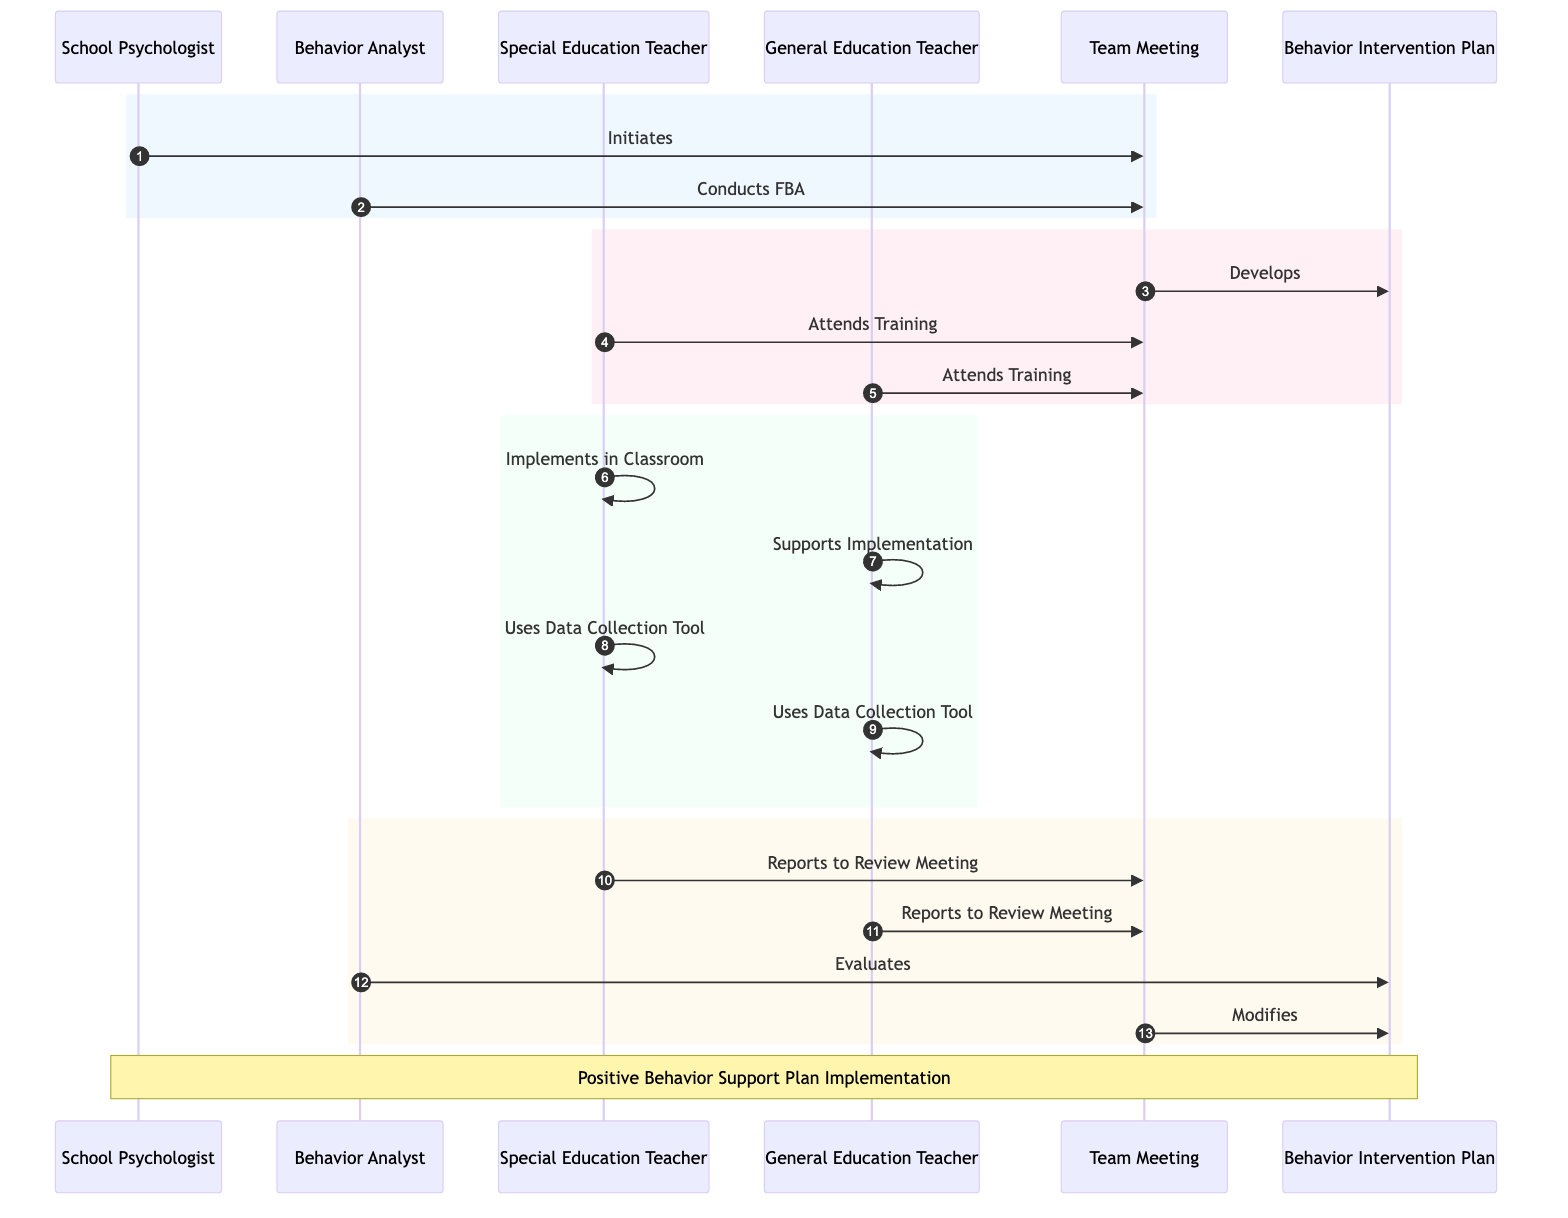What is the first action initiated in this sequence? The first action depicted in the diagram is the School Psychologist initiating the Team Meeting. This can be identified as the first arrow from the School Psychologist pointing to the Team Meeting in the sequence of actions.
Answer: Team Meeting How many teachers are involved in the Training Session? In the diagram, both the Special Education Teacher and General Education Teacher attend the Teacher Training Session. Thus, there are two teachers involved in this action.
Answer: Two Who evaluates the Behavior Intervention Plan? The Behavior Analyst is the one who evaluates the Behavior Intervention Plan, as shown by the arrow pointing from the Behavior Analyst to the Behavior Intervention Plan after the Periodic Review Meeting.
Answer: Behavior Analyst What is the trigger for the Classroom Implementation? The trigger for the Classroom Implementation is the Teacher Training Session, as indicated in the arrows leading from the Teacher Training Session to the implementations by both the Special Education Teacher and the General Education Teacher.
Answer: Teacher Training Session Which action follows the Periodic Review Meeting? Following the Periodic Review Meeting, the Behavior Analyst evaluates the Behavior Intervention Plan. This sequence can be tracked by looking at the arrow that leads from the Periodic Review Meeting to the Behavior Intervention Plan evaluation.
Answer: Evaluates How many actions occur between the initiation of the Team Meeting and the evaluation of the BIP? The actions that occur between the initiation of the Team Meeting and the evaluation of the BIP include conducting the FBA, developing the BIP, attending the Teacher Training Sessions, implementing in the classroom, using the Data Collection Tool, and reporting to the Periodic Review Meeting, which totals six distinct actions.
Answer: Six What happens to the Behavior Intervention Plan after the evaluation? After the evaluation, the Behavior Intervention Plan is modified during the subsequent Team Meeting, as shown by the arrows indicating an action following the evaluation process.
Answer: Modifies Which actors are involved in using the Data Collection Tool? Both the Special Education Teacher and the General Education Teacher are involved in using the Data Collection Tool, with actions shown in the diagram connecting these roles to the tool usage following the Classroom Implementation.
Answer: Special Education Teacher and General Education Teacher 